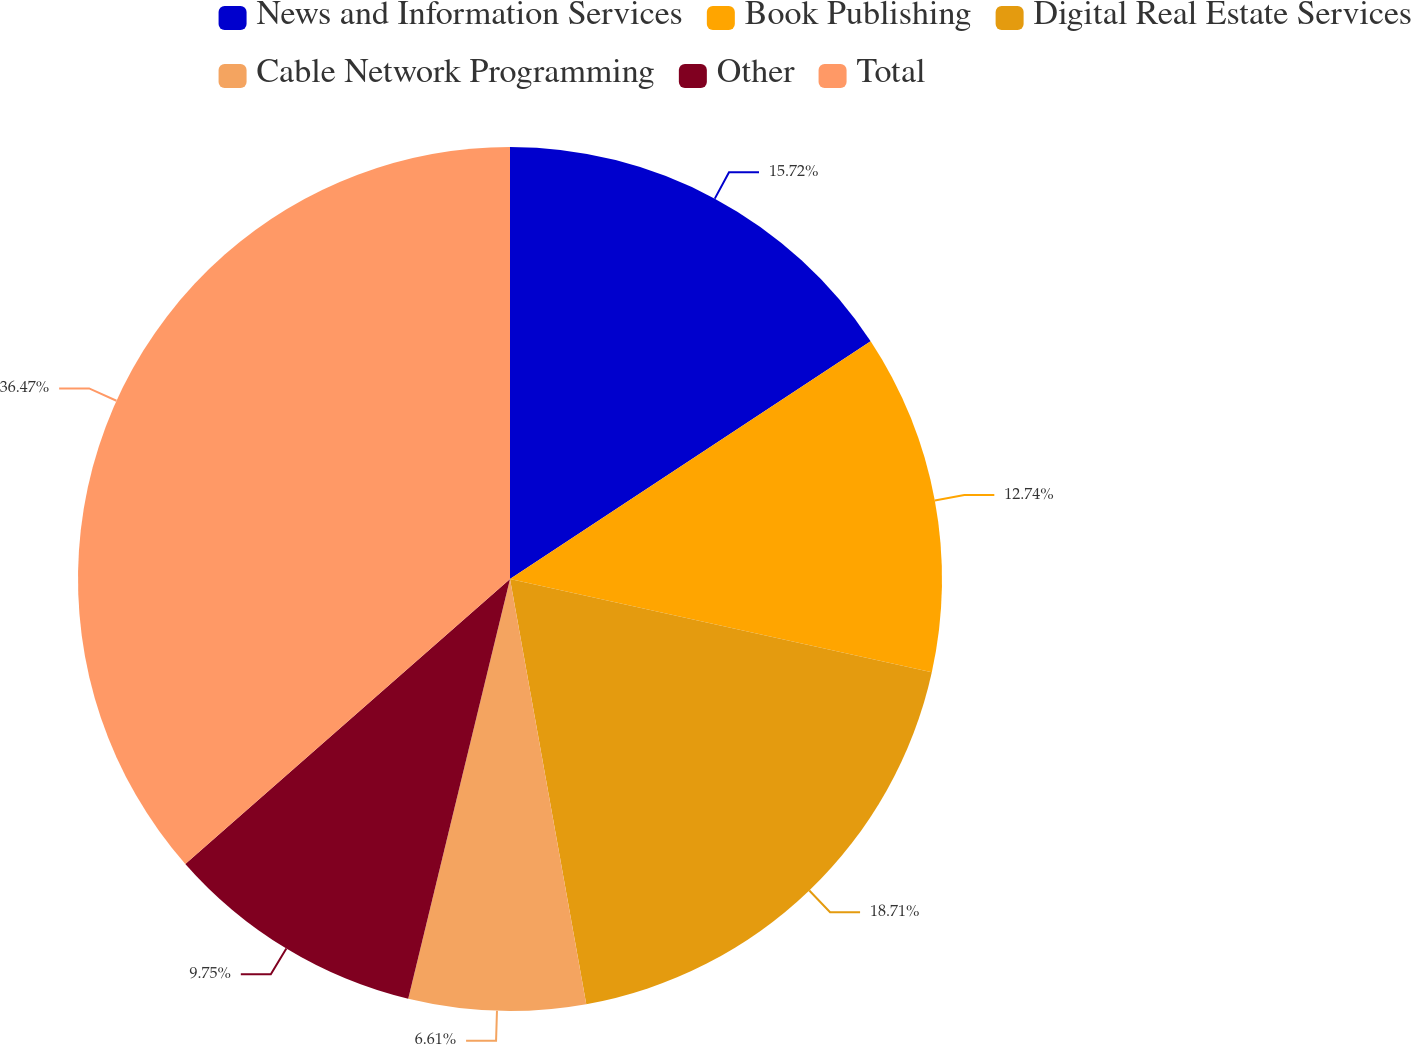<chart> <loc_0><loc_0><loc_500><loc_500><pie_chart><fcel>News and Information Services<fcel>Book Publishing<fcel>Digital Real Estate Services<fcel>Cable Network Programming<fcel>Other<fcel>Total<nl><fcel>15.72%<fcel>12.74%<fcel>18.71%<fcel>6.61%<fcel>9.75%<fcel>36.46%<nl></chart> 